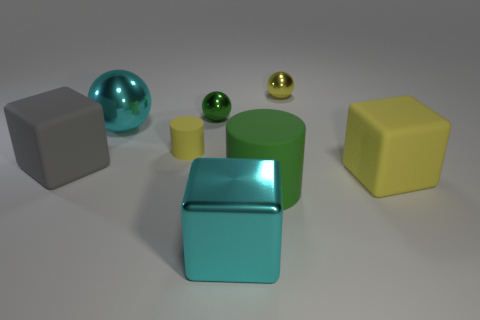Add 1 large cyan objects. How many objects exist? 9 Subtract all shiny cubes. How many cubes are left? 2 Subtract all cyan spheres. How many spheres are left? 2 Subtract 3 cubes. How many cubes are left? 0 Subtract all yellow balls. Subtract all green cylinders. How many balls are left? 2 Subtract all large rubber blocks. Subtract all yellow rubber objects. How many objects are left? 4 Add 8 large gray rubber cubes. How many large gray rubber cubes are left? 9 Add 4 green spheres. How many green spheres exist? 5 Subtract 0 red blocks. How many objects are left? 8 Subtract all cylinders. How many objects are left? 6 